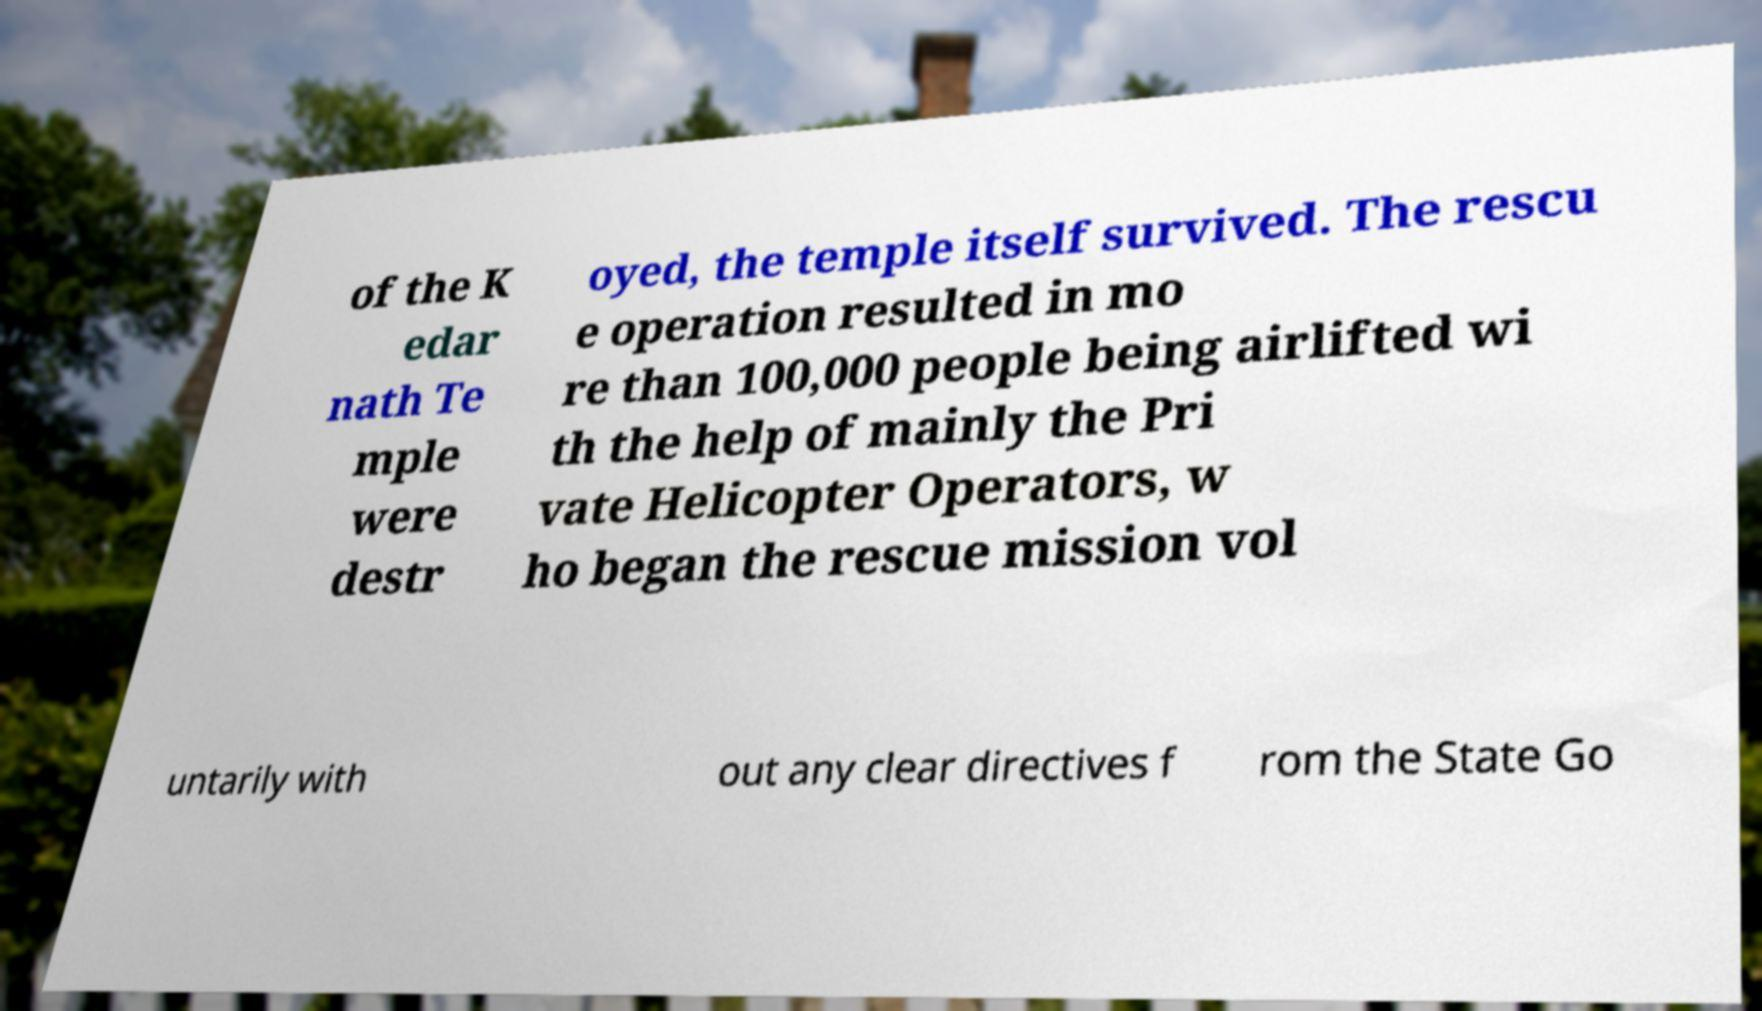Please identify and transcribe the text found in this image. of the K edar nath Te mple were destr oyed, the temple itself survived. The rescu e operation resulted in mo re than 100,000 people being airlifted wi th the help of mainly the Pri vate Helicopter Operators, w ho began the rescue mission vol untarily with out any clear directives f rom the State Go 